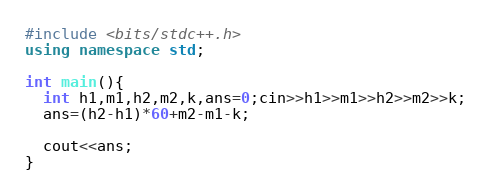<code> <loc_0><loc_0><loc_500><loc_500><_C++_>#include <bits/stdc++.h>
using namespace std;

int main(){
  int h1,m1,h2,m2,k,ans=0;cin>>h1>>m1>>h2>>m2>>k;
  ans=(h2-h1)*60+m2-m1-k;

  cout<<ans;
}</code> 